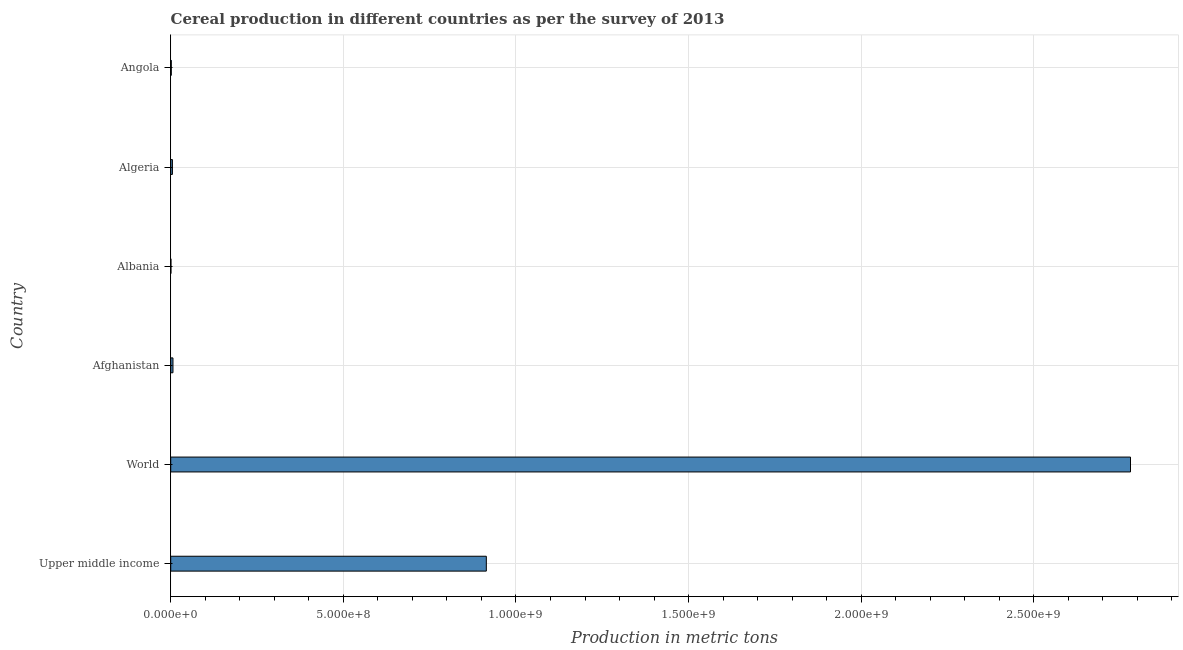Does the graph contain any zero values?
Make the answer very short. No. Does the graph contain grids?
Provide a short and direct response. Yes. What is the title of the graph?
Your answer should be compact. Cereal production in different countries as per the survey of 2013. What is the label or title of the X-axis?
Keep it short and to the point. Production in metric tons. What is the cereal production in Albania?
Offer a very short reply. 6.60e+05. Across all countries, what is the maximum cereal production?
Offer a terse response. 2.78e+09. Across all countries, what is the minimum cereal production?
Give a very brief answer. 6.60e+05. In which country was the cereal production maximum?
Offer a very short reply. World. In which country was the cereal production minimum?
Keep it short and to the point. Albania. What is the sum of the cereal production?
Offer a very short reply. 3.71e+09. What is the difference between the cereal production in Albania and World?
Your answer should be very brief. -2.78e+09. What is the average cereal production per country?
Your response must be concise. 6.18e+08. What is the median cereal production?
Keep it short and to the point. 5.72e+06. In how many countries, is the cereal production greater than 800000000 metric tons?
Offer a terse response. 2. What is the ratio of the cereal production in Algeria to that in Angola?
Provide a short and direct response. 2.93. Is the cereal production in Afghanistan less than that in Albania?
Provide a short and direct response. No. Is the difference between the cereal production in Albania and Algeria greater than the difference between any two countries?
Your answer should be very brief. No. What is the difference between the highest and the second highest cereal production?
Your answer should be very brief. 1.87e+09. Is the sum of the cereal production in Albania and Upper middle income greater than the maximum cereal production across all countries?
Make the answer very short. No. What is the difference between the highest and the lowest cereal production?
Give a very brief answer. 2.78e+09. In how many countries, is the cereal production greater than the average cereal production taken over all countries?
Your answer should be very brief. 2. Are all the bars in the graph horizontal?
Make the answer very short. Yes. How many countries are there in the graph?
Provide a short and direct response. 6. What is the difference between two consecutive major ticks on the X-axis?
Give a very brief answer. 5.00e+08. Are the values on the major ticks of X-axis written in scientific E-notation?
Your answer should be very brief. Yes. What is the Production in metric tons of Upper middle income?
Your answer should be very brief. 9.14e+08. What is the Production in metric tons of World?
Provide a short and direct response. 2.78e+09. What is the Production in metric tons of Afghanistan?
Your answer should be very brief. 6.52e+06. What is the Production in metric tons in Albania?
Offer a very short reply. 6.60e+05. What is the Production in metric tons of Algeria?
Provide a succinct answer. 4.91e+06. What is the Production in metric tons of Angola?
Provide a succinct answer. 1.68e+06. What is the difference between the Production in metric tons in Upper middle income and World?
Offer a very short reply. -1.87e+09. What is the difference between the Production in metric tons in Upper middle income and Afghanistan?
Make the answer very short. 9.08e+08. What is the difference between the Production in metric tons in Upper middle income and Albania?
Make the answer very short. 9.13e+08. What is the difference between the Production in metric tons in Upper middle income and Algeria?
Your response must be concise. 9.09e+08. What is the difference between the Production in metric tons in Upper middle income and Angola?
Keep it short and to the point. 9.12e+08. What is the difference between the Production in metric tons in World and Afghanistan?
Your answer should be compact. 2.77e+09. What is the difference between the Production in metric tons in World and Albania?
Make the answer very short. 2.78e+09. What is the difference between the Production in metric tons in World and Algeria?
Keep it short and to the point. 2.78e+09. What is the difference between the Production in metric tons in World and Angola?
Your response must be concise. 2.78e+09. What is the difference between the Production in metric tons in Afghanistan and Albania?
Provide a short and direct response. 5.86e+06. What is the difference between the Production in metric tons in Afghanistan and Algeria?
Ensure brevity in your answer.  1.61e+06. What is the difference between the Production in metric tons in Afghanistan and Angola?
Your answer should be very brief. 4.84e+06. What is the difference between the Production in metric tons in Albania and Algeria?
Offer a very short reply. -4.25e+06. What is the difference between the Production in metric tons in Albania and Angola?
Ensure brevity in your answer.  -1.01e+06. What is the difference between the Production in metric tons in Algeria and Angola?
Your response must be concise. 3.24e+06. What is the ratio of the Production in metric tons in Upper middle income to that in World?
Provide a short and direct response. 0.33. What is the ratio of the Production in metric tons in Upper middle income to that in Afghanistan?
Your answer should be compact. 140.2. What is the ratio of the Production in metric tons in Upper middle income to that in Albania?
Ensure brevity in your answer.  1384.02. What is the ratio of the Production in metric tons in Upper middle income to that in Algeria?
Keep it short and to the point. 186.03. What is the ratio of the Production in metric tons in Upper middle income to that in Angola?
Offer a very short reply. 545.64. What is the ratio of the Production in metric tons in World to that in Afghanistan?
Ensure brevity in your answer.  426.35. What is the ratio of the Production in metric tons in World to that in Albania?
Your answer should be compact. 4208.81. What is the ratio of the Production in metric tons in World to that in Algeria?
Your answer should be very brief. 565.71. What is the ratio of the Production in metric tons in World to that in Angola?
Your answer should be compact. 1659.31. What is the ratio of the Production in metric tons in Afghanistan to that in Albania?
Provide a short and direct response. 9.87. What is the ratio of the Production in metric tons in Afghanistan to that in Algeria?
Offer a very short reply. 1.33. What is the ratio of the Production in metric tons in Afghanistan to that in Angola?
Provide a succinct answer. 3.89. What is the ratio of the Production in metric tons in Albania to that in Algeria?
Provide a succinct answer. 0.13. What is the ratio of the Production in metric tons in Albania to that in Angola?
Keep it short and to the point. 0.39. What is the ratio of the Production in metric tons in Algeria to that in Angola?
Your answer should be very brief. 2.93. 